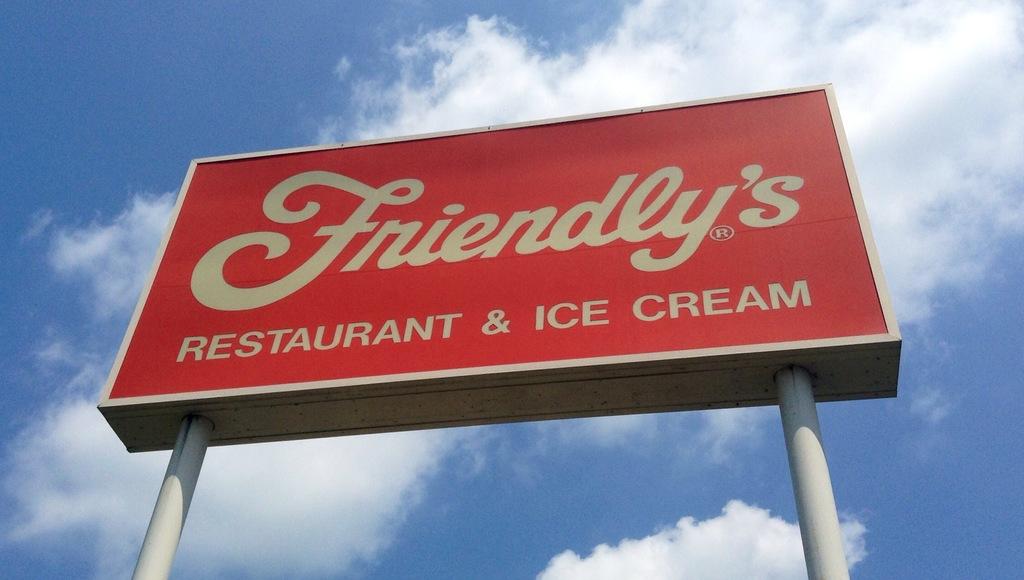What does friendly's offer?
Your answer should be compact. Restaurant and ice cream. 